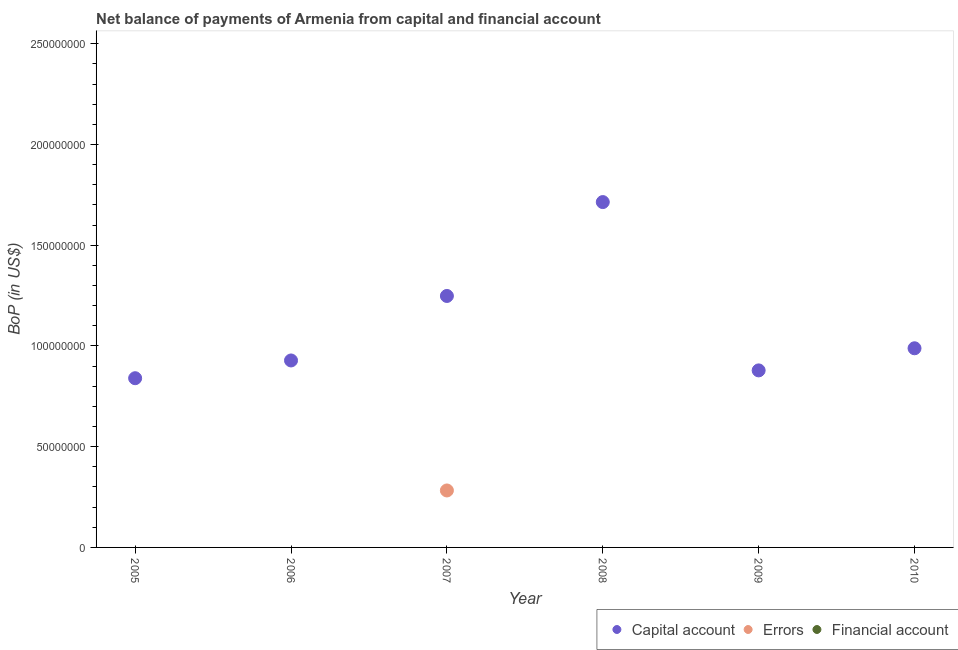How many different coloured dotlines are there?
Your response must be concise. 2. What is the amount of errors in 2010?
Provide a short and direct response. 0. Across all years, what is the maximum amount of errors?
Make the answer very short. 2.83e+07. In which year was the amount of errors maximum?
Offer a very short reply. 2007. What is the total amount of errors in the graph?
Your answer should be compact. 2.83e+07. What is the difference between the amount of net capital account in 2005 and that in 2006?
Your answer should be very brief. -8.81e+06. What is the difference between the amount of net capital account in 2007 and the amount of financial account in 2005?
Ensure brevity in your answer.  1.25e+08. What is the average amount of net capital account per year?
Keep it short and to the point. 1.10e+08. In how many years, is the amount of errors greater than 180000000 US$?
Offer a very short reply. 0. What is the difference between the highest and the second highest amount of net capital account?
Ensure brevity in your answer.  4.66e+07. What is the difference between the highest and the lowest amount of net capital account?
Keep it short and to the point. 8.74e+07. Is the sum of the amount of net capital account in 2005 and 2009 greater than the maximum amount of financial account across all years?
Keep it short and to the point. Yes. Is it the case that in every year, the sum of the amount of net capital account and amount of errors is greater than the amount of financial account?
Keep it short and to the point. Yes. Is the amount of errors strictly greater than the amount of financial account over the years?
Ensure brevity in your answer.  Yes. What is the difference between two consecutive major ticks on the Y-axis?
Provide a succinct answer. 5.00e+07. Are the values on the major ticks of Y-axis written in scientific E-notation?
Provide a succinct answer. No. Does the graph contain any zero values?
Your answer should be compact. Yes. Does the graph contain grids?
Provide a short and direct response. No. How many legend labels are there?
Ensure brevity in your answer.  3. How are the legend labels stacked?
Provide a succinct answer. Horizontal. What is the title of the graph?
Provide a short and direct response. Net balance of payments of Armenia from capital and financial account. What is the label or title of the X-axis?
Provide a succinct answer. Year. What is the label or title of the Y-axis?
Keep it short and to the point. BoP (in US$). What is the BoP (in US$) in Capital account in 2005?
Your response must be concise. 8.40e+07. What is the BoP (in US$) of Financial account in 2005?
Offer a very short reply. 0. What is the BoP (in US$) of Capital account in 2006?
Ensure brevity in your answer.  9.28e+07. What is the BoP (in US$) in Errors in 2006?
Offer a very short reply. 0. What is the BoP (in US$) of Capital account in 2007?
Make the answer very short. 1.25e+08. What is the BoP (in US$) of Errors in 2007?
Provide a succinct answer. 2.83e+07. What is the BoP (in US$) in Capital account in 2008?
Keep it short and to the point. 1.71e+08. What is the BoP (in US$) in Capital account in 2009?
Offer a terse response. 8.79e+07. What is the BoP (in US$) in Errors in 2009?
Provide a short and direct response. 0. What is the BoP (in US$) in Financial account in 2009?
Ensure brevity in your answer.  0. What is the BoP (in US$) of Capital account in 2010?
Give a very brief answer. 9.89e+07. Across all years, what is the maximum BoP (in US$) of Capital account?
Provide a short and direct response. 1.71e+08. Across all years, what is the maximum BoP (in US$) of Errors?
Offer a terse response. 2.83e+07. Across all years, what is the minimum BoP (in US$) of Capital account?
Provide a succinct answer. 8.40e+07. Across all years, what is the minimum BoP (in US$) of Errors?
Make the answer very short. 0. What is the total BoP (in US$) of Capital account in the graph?
Your answer should be very brief. 6.60e+08. What is the total BoP (in US$) in Errors in the graph?
Your answer should be compact. 2.83e+07. What is the difference between the BoP (in US$) in Capital account in 2005 and that in 2006?
Offer a terse response. -8.81e+06. What is the difference between the BoP (in US$) in Capital account in 2005 and that in 2007?
Ensure brevity in your answer.  -4.08e+07. What is the difference between the BoP (in US$) of Capital account in 2005 and that in 2008?
Your response must be concise. -8.74e+07. What is the difference between the BoP (in US$) of Capital account in 2005 and that in 2009?
Ensure brevity in your answer.  -3.88e+06. What is the difference between the BoP (in US$) in Capital account in 2005 and that in 2010?
Keep it short and to the point. -1.49e+07. What is the difference between the BoP (in US$) of Capital account in 2006 and that in 2007?
Your answer should be compact. -3.20e+07. What is the difference between the BoP (in US$) in Capital account in 2006 and that in 2008?
Give a very brief answer. -7.86e+07. What is the difference between the BoP (in US$) of Capital account in 2006 and that in 2009?
Give a very brief answer. 4.93e+06. What is the difference between the BoP (in US$) in Capital account in 2006 and that in 2010?
Keep it short and to the point. -6.05e+06. What is the difference between the BoP (in US$) of Capital account in 2007 and that in 2008?
Ensure brevity in your answer.  -4.66e+07. What is the difference between the BoP (in US$) in Capital account in 2007 and that in 2009?
Offer a terse response. 3.70e+07. What is the difference between the BoP (in US$) in Capital account in 2007 and that in 2010?
Ensure brevity in your answer.  2.60e+07. What is the difference between the BoP (in US$) in Capital account in 2008 and that in 2009?
Your answer should be very brief. 8.36e+07. What is the difference between the BoP (in US$) of Capital account in 2008 and that in 2010?
Your response must be concise. 7.26e+07. What is the difference between the BoP (in US$) of Capital account in 2009 and that in 2010?
Offer a very short reply. -1.10e+07. What is the difference between the BoP (in US$) of Capital account in 2005 and the BoP (in US$) of Errors in 2007?
Provide a short and direct response. 5.57e+07. What is the difference between the BoP (in US$) of Capital account in 2006 and the BoP (in US$) of Errors in 2007?
Provide a short and direct response. 6.45e+07. What is the average BoP (in US$) of Capital account per year?
Your answer should be very brief. 1.10e+08. What is the average BoP (in US$) in Errors per year?
Ensure brevity in your answer.  4.71e+06. What is the average BoP (in US$) in Financial account per year?
Make the answer very short. 0. In the year 2007, what is the difference between the BoP (in US$) in Capital account and BoP (in US$) in Errors?
Keep it short and to the point. 9.66e+07. What is the ratio of the BoP (in US$) in Capital account in 2005 to that in 2006?
Offer a terse response. 0.91. What is the ratio of the BoP (in US$) in Capital account in 2005 to that in 2007?
Offer a very short reply. 0.67. What is the ratio of the BoP (in US$) of Capital account in 2005 to that in 2008?
Provide a succinct answer. 0.49. What is the ratio of the BoP (in US$) in Capital account in 2005 to that in 2009?
Ensure brevity in your answer.  0.96. What is the ratio of the BoP (in US$) of Capital account in 2005 to that in 2010?
Your response must be concise. 0.85. What is the ratio of the BoP (in US$) of Capital account in 2006 to that in 2007?
Offer a terse response. 0.74. What is the ratio of the BoP (in US$) in Capital account in 2006 to that in 2008?
Give a very brief answer. 0.54. What is the ratio of the BoP (in US$) in Capital account in 2006 to that in 2009?
Make the answer very short. 1.06. What is the ratio of the BoP (in US$) in Capital account in 2006 to that in 2010?
Your response must be concise. 0.94. What is the ratio of the BoP (in US$) of Capital account in 2007 to that in 2008?
Keep it short and to the point. 0.73. What is the ratio of the BoP (in US$) of Capital account in 2007 to that in 2009?
Keep it short and to the point. 1.42. What is the ratio of the BoP (in US$) of Capital account in 2007 to that in 2010?
Keep it short and to the point. 1.26. What is the ratio of the BoP (in US$) in Capital account in 2008 to that in 2009?
Your answer should be very brief. 1.95. What is the ratio of the BoP (in US$) of Capital account in 2008 to that in 2010?
Make the answer very short. 1.73. What is the difference between the highest and the second highest BoP (in US$) of Capital account?
Your answer should be very brief. 4.66e+07. What is the difference between the highest and the lowest BoP (in US$) of Capital account?
Keep it short and to the point. 8.74e+07. What is the difference between the highest and the lowest BoP (in US$) in Errors?
Your answer should be compact. 2.83e+07. 